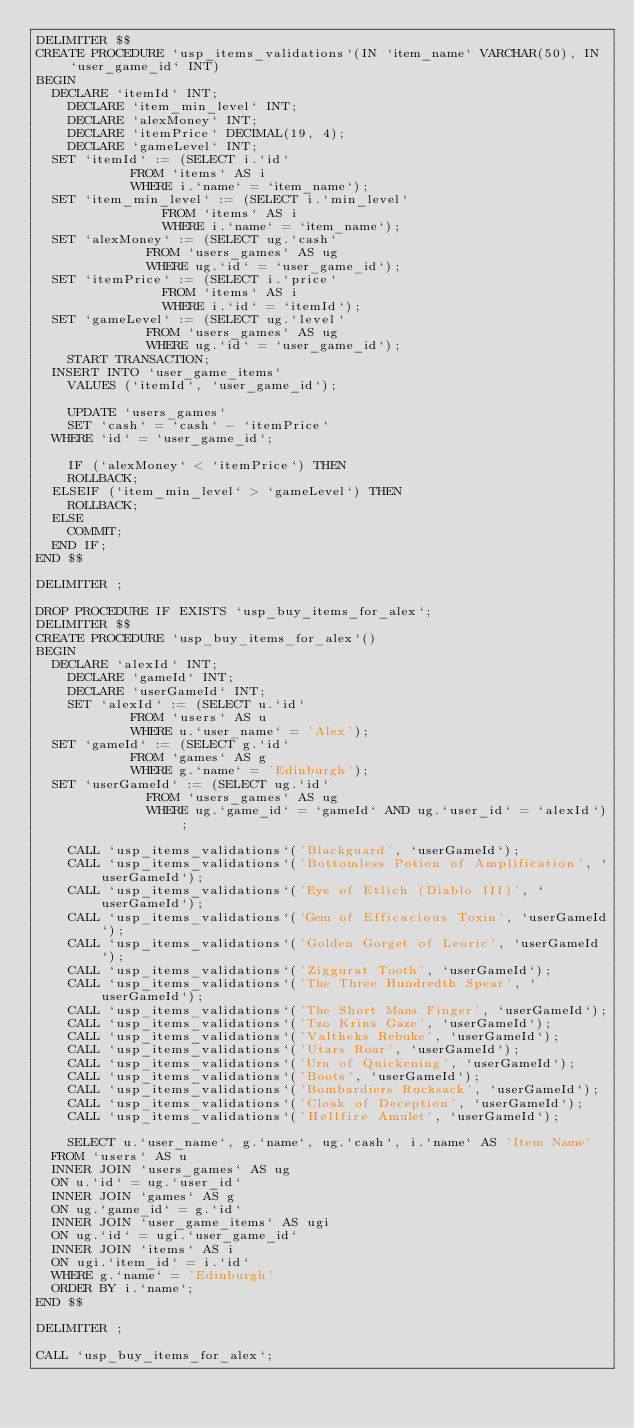Convert code to text. <code><loc_0><loc_0><loc_500><loc_500><_SQL_>DELIMITER $$
CREATE PROCEDURE `usp_items_validations`(IN `item_name` VARCHAR(50), IN `user_game_id` INT)
BEGIN
	DECLARE `itemId` INT;    
    DECLARE `item_min_level` INT;
    DECLARE `alexMoney` INT;
    DECLARE `itemPrice` DECIMAL(19, 4);
    DECLARE `gameLevel` INT;
	SET `itemId` := (SELECT i.`id`
						FROM `items` AS i
						WHERE i.`name` = `item_name`);
	SET `item_min_level` := (SELECT i.`min_level`
								FROM `items` AS i
								WHERE i.`name` = `item_name`);
	SET `alexMoney` := (SELECT ug.`cash`
							FROM `users_games` AS ug
							WHERE ug.`id` = `user_game_id`);
	SET `itemPrice` := (SELECT i.`price`
								FROM `items` AS i
								WHERE i.`id` = `itemId`);
	SET `gameLevel` := (SELECT ug.`level`
							FROM `users_games` AS ug
							WHERE ug.`id` = `user_game_id`);
    START TRANSACTION;
	INSERT INTO `user_game_items`
    VALUES (`itemId`, `user_game_id`);
    
    UPDATE `users_games`
    SET `cash` = `cash` - `itemPrice`
	WHERE `id` = `user_game_id`;
	
    IF (`alexMoney` < `itemPrice`) THEN
		ROLLBACK;
	ELSEIF (`item_min_level` > `gameLevel`) THEN
		ROLLBACK;
	ELSE
		COMMIT;
	END IF;
END $$

DELIMITER ;

DROP PROCEDURE IF EXISTS `usp_buy_items_for_alex`;
DELIMITER $$
CREATE PROCEDURE `usp_buy_items_for_alex`()
BEGIN
	DECLARE `alexId` INT;
    DECLARE `gameId` INT;    
    DECLARE `userGameId` INT;
    SET `alexId` := (SELECT u.`id`
						FROM `users` AS u
						WHERE u.`user_name` = 'Alex');
	SET `gameId` := (SELECT g.`id`
						FROM `games` AS g
						WHERE g.`name` = 'Edinburgh');
	SET `userGameId` := (SELECT ug.`id`
							FROM `users_games` AS ug
							WHERE ug.`game_id` = `gameId` AND ug.`user_id` = `alexId`);
	
    CALL `usp_items_validations`('Blackguard', `userGameId`);
    CALL `usp_items_validations`('Bottomless Potion of Amplification', `userGameId`);
    CALL `usp_items_validations`('Eye of Etlich (Diablo III)', `userGameId`);
    CALL `usp_items_validations`('Gem of Efficacious Toxin', `userGameId`);
    CALL `usp_items_validations`('Golden Gorget of Leoric', `userGameId`);
    CALL `usp_items_validations`('Ziggurat Tooth', `userGameId`);
    CALL `usp_items_validations`('The Three Hundredth Spear', `userGameId`);
    CALL `usp_items_validations`('The Short Mans Finger', `userGameId`);
    CALL `usp_items_validations`('Tzo Krins Gaze', `userGameId`);
    CALL `usp_items_validations`('Valtheks Rebuke', `userGameId`);
    CALL `usp_items_validations`('Utars Roar', `userGameId`);
    CALL `usp_items_validations`('Urn of Quickening', `userGameId`);
    CALL `usp_items_validations`('Boots', `userGameId`);
    CALL `usp_items_validations`('Bombardiers Rucksack', `userGameId`);
    CALL `usp_items_validations`('Cloak of Deception', `userGameId`);
    CALL `usp_items_validations`('Hellfire Amulet', `userGameId`);
    
    SELECT u.`user_name`, g.`name`, ug.`cash`, i.`name` AS 'Item Name'
	FROM `users` AS u
	INNER JOIN `users_games` AS ug
	ON u.`id` = ug.`user_id`
	INNER JOIN `games` AS g
	ON ug.`game_id` = g.`id`
	INNER JOIN `user_game_items` AS ugi
	ON ug.`id` = ugi.`user_game_id`
	INNER JOIN `items` AS i
	ON ugi.`item_id` = i.`id`
	WHERE g.`name` = 'Edinburgh'
	ORDER BY i.`name`;
END $$

DELIMITER ;

CALL `usp_buy_items_for_alex`;</code> 